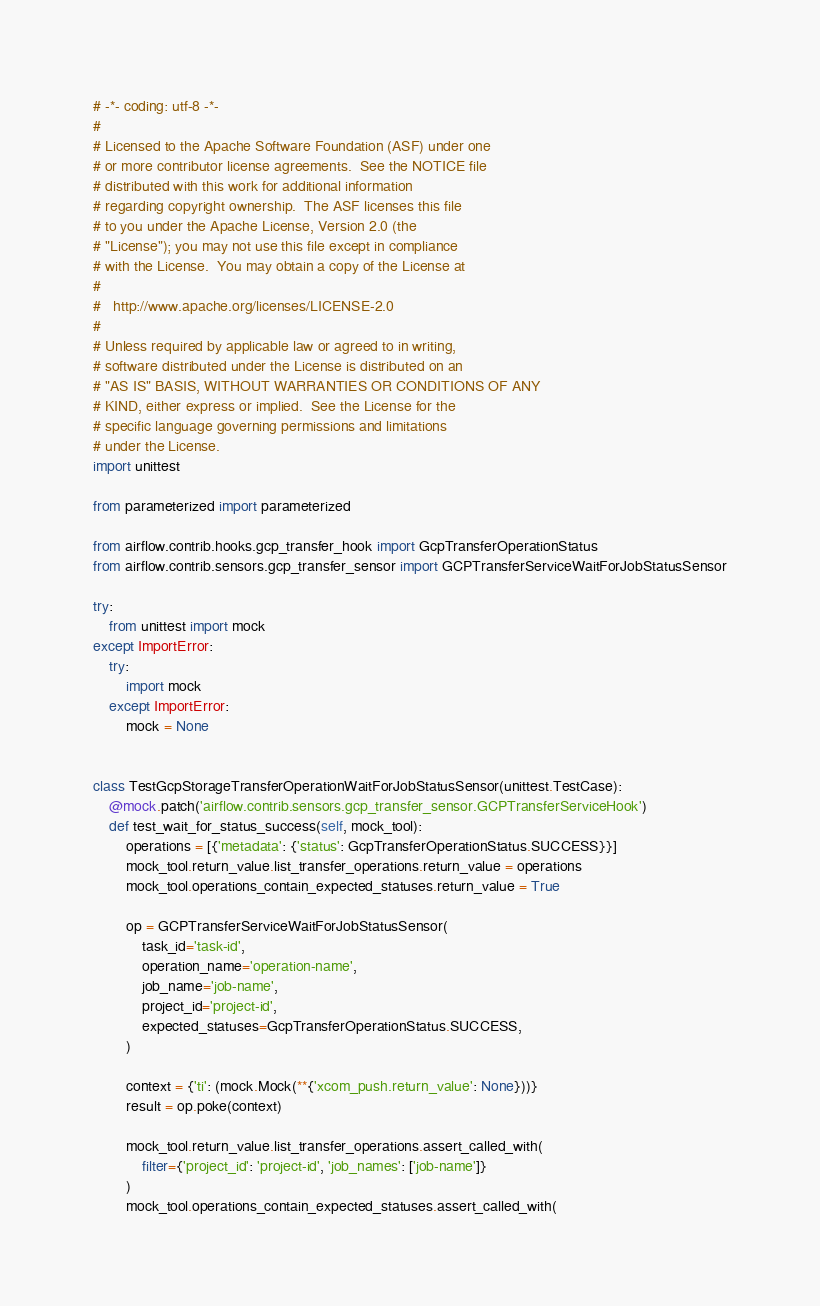<code> <loc_0><loc_0><loc_500><loc_500><_Python_># -*- coding: utf-8 -*-
#
# Licensed to the Apache Software Foundation (ASF) under one
# or more contributor license agreements.  See the NOTICE file
# distributed with this work for additional information
# regarding copyright ownership.  The ASF licenses this file
# to you under the Apache License, Version 2.0 (the
# "License"); you may not use this file except in compliance
# with the License.  You may obtain a copy of the License at
#
#   http://www.apache.org/licenses/LICENSE-2.0
#
# Unless required by applicable law or agreed to in writing,
# software distributed under the License is distributed on an
# "AS IS" BASIS, WITHOUT WARRANTIES OR CONDITIONS OF ANY
# KIND, either express or implied.  See the License for the
# specific language governing permissions and limitations
# under the License.
import unittest

from parameterized import parameterized

from airflow.contrib.hooks.gcp_transfer_hook import GcpTransferOperationStatus
from airflow.contrib.sensors.gcp_transfer_sensor import GCPTransferServiceWaitForJobStatusSensor

try:
    from unittest import mock
except ImportError:
    try:
        import mock
    except ImportError:
        mock = None


class TestGcpStorageTransferOperationWaitForJobStatusSensor(unittest.TestCase):
    @mock.patch('airflow.contrib.sensors.gcp_transfer_sensor.GCPTransferServiceHook')
    def test_wait_for_status_success(self, mock_tool):
        operations = [{'metadata': {'status': GcpTransferOperationStatus.SUCCESS}}]
        mock_tool.return_value.list_transfer_operations.return_value = operations
        mock_tool.operations_contain_expected_statuses.return_value = True

        op = GCPTransferServiceWaitForJobStatusSensor(
            task_id='task-id',
            operation_name='operation-name',
            job_name='job-name',
            project_id='project-id',
            expected_statuses=GcpTransferOperationStatus.SUCCESS,
        )

        context = {'ti': (mock.Mock(**{'xcom_push.return_value': None}))}
        result = op.poke(context)

        mock_tool.return_value.list_transfer_operations.assert_called_with(
            filter={'project_id': 'project-id', 'job_names': ['job-name']}
        )
        mock_tool.operations_contain_expected_statuses.assert_called_with(</code> 